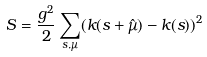Convert formula to latex. <formula><loc_0><loc_0><loc_500><loc_500>S = \frac { g ^ { 2 } } { 2 } \sum _ { s , \mu } ( k ( s + \hat { \mu } ) - k ( s ) ) ^ { 2 }</formula> 